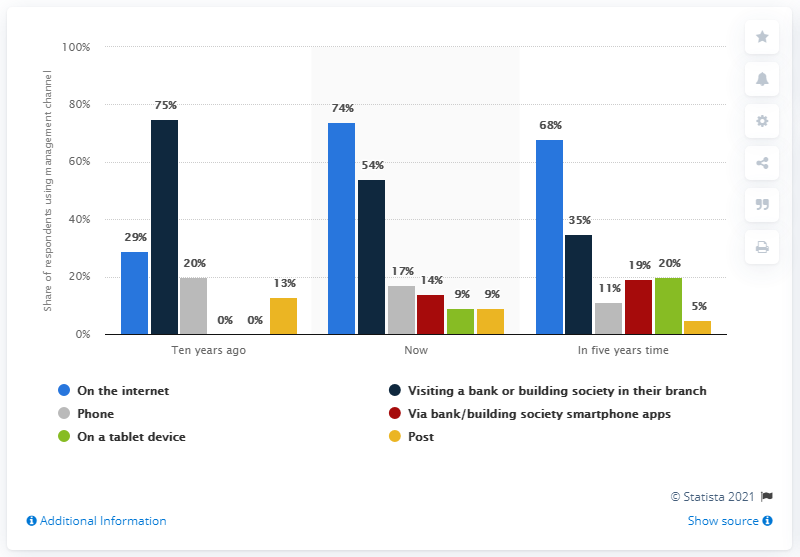Point out several critical features in this image. The light blue bar on the internet represents a visual representation of information. The difference in the average blue bar level between ten years ago and now is 45%. 